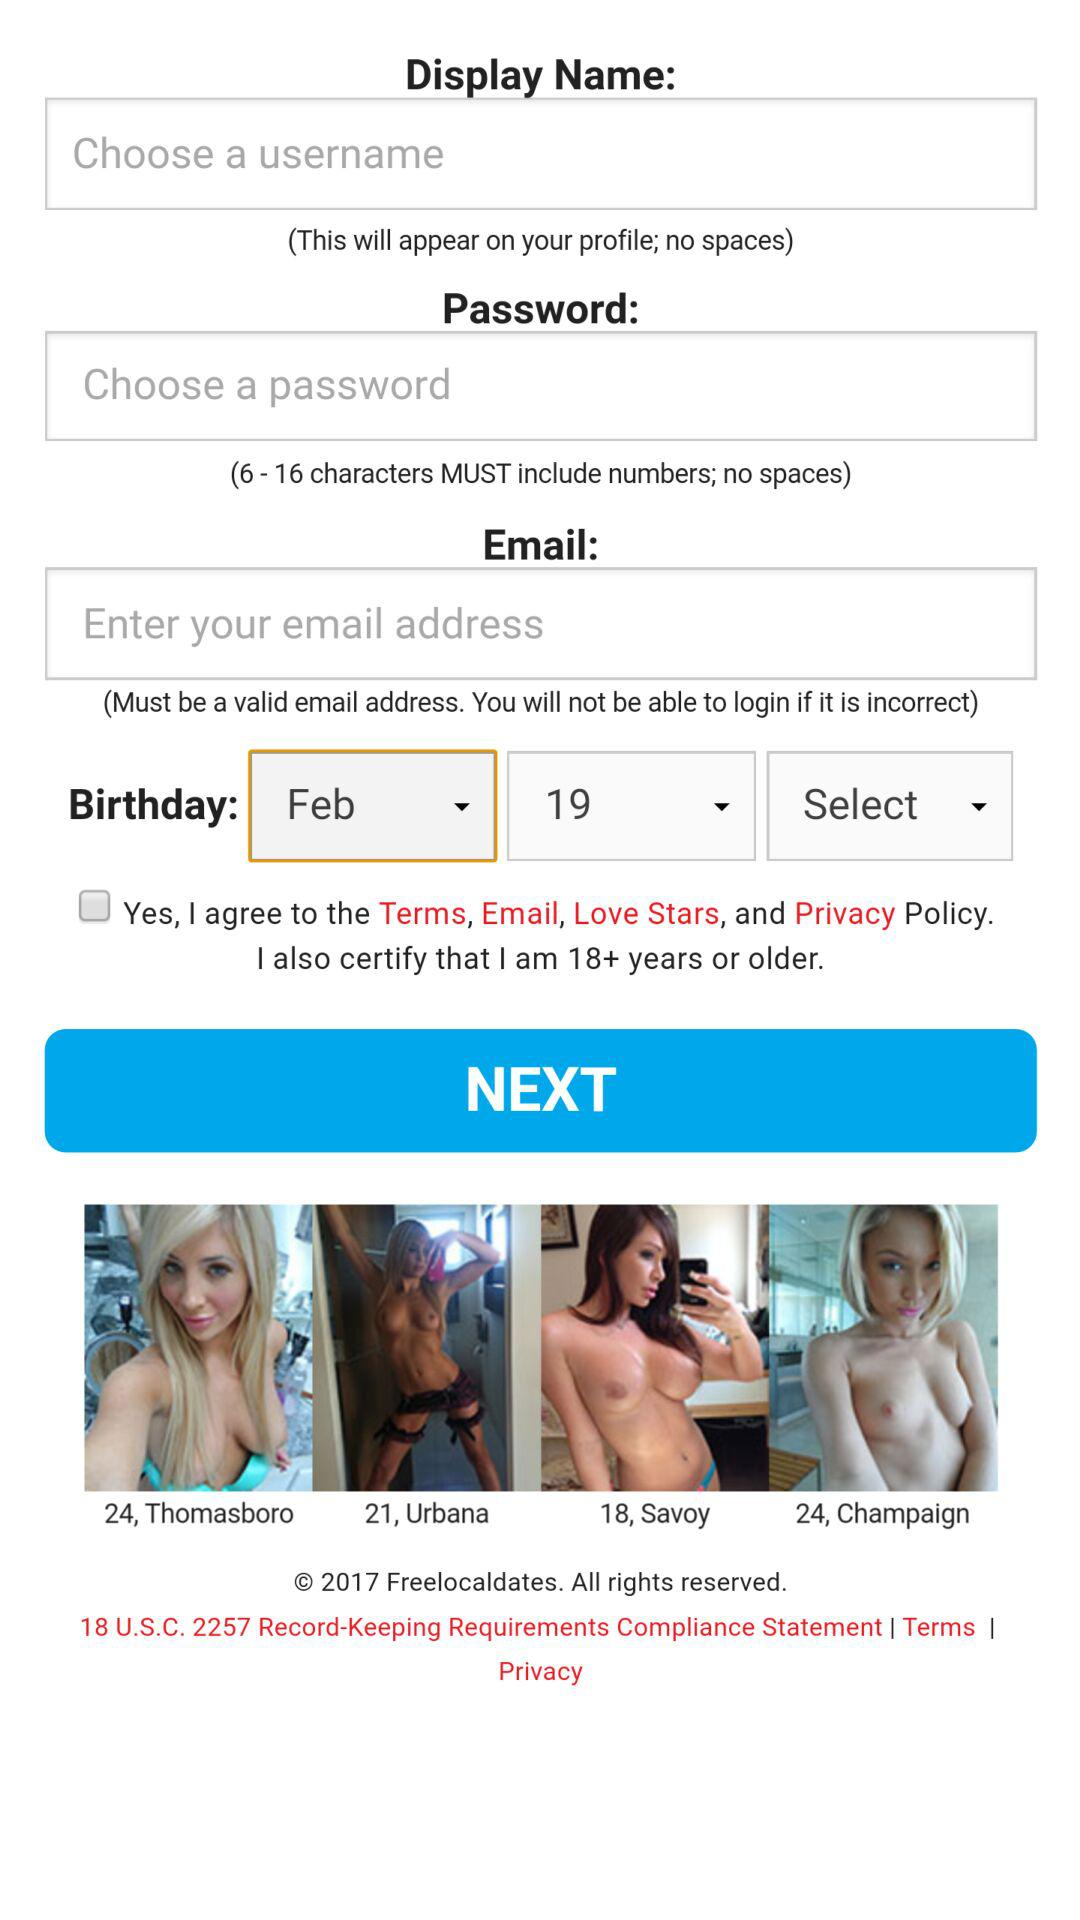What is the birthday date? The birthday date is February 19. 